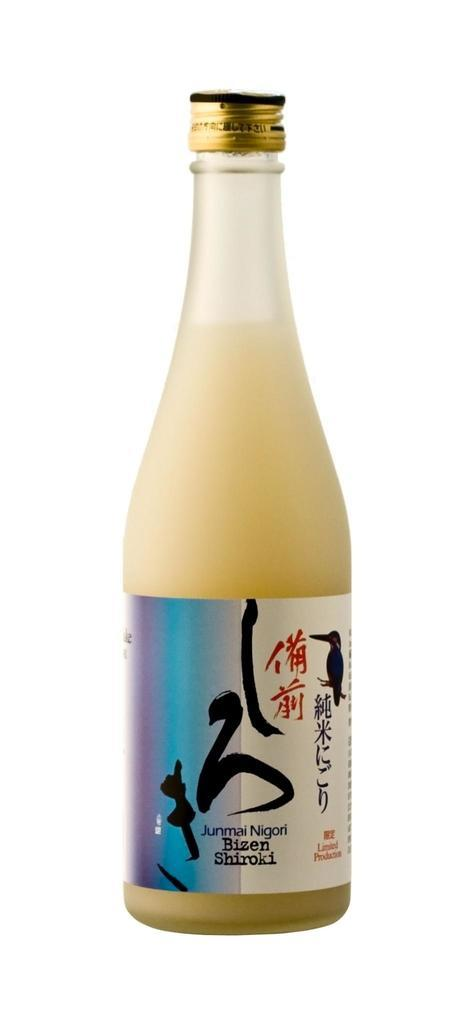What type of container is visible in the image? There is a glass bottle in the image. What feature can be seen on the glass bottle? The glass bottle has a cap. What type of coal is being used to knit wool in the image? There is no coal or wool present in the image; it only features a glass bottle with a cap. 